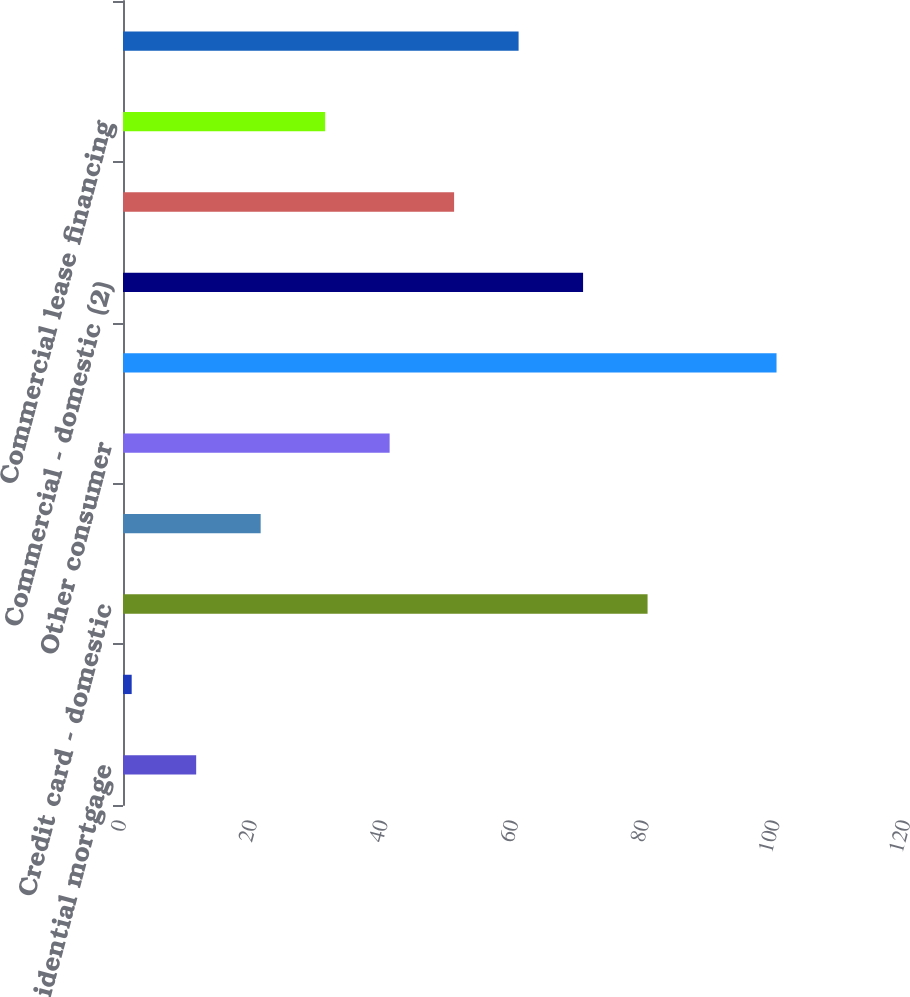Convert chart to OTSL. <chart><loc_0><loc_0><loc_500><loc_500><bar_chart><fcel>Residential mortgage<fcel>Home equity<fcel>Credit card - domestic<fcel>Direct/Indirect consumer<fcel>Other consumer<fcel>Total consumer<fcel>Commercial - domestic (2)<fcel>Commercial real estate<fcel>Commercial lease financing<fcel>Commercial - foreign<nl><fcel>11.2<fcel>1.33<fcel>80.29<fcel>21.07<fcel>40.81<fcel>100.03<fcel>70.42<fcel>50.68<fcel>30.94<fcel>60.55<nl></chart> 